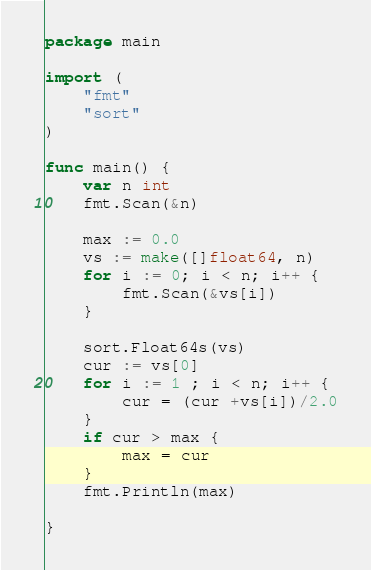Convert code to text. <code><loc_0><loc_0><loc_500><loc_500><_Go_>package main

import (
	"fmt"
	"sort"
)

func main() {
	var n int
	fmt.Scan(&n)

	max := 0.0
	vs := make([]float64, n)
	for i := 0; i < n; i++ {
		fmt.Scan(&vs[i])
	}

	sort.Float64s(vs)
	cur := vs[0]
	for i := 1 ; i < n; i++ {
		cur = (cur +vs[i])/2.0
	}
	if cur > max {
		max = cur
	}
	fmt.Println(max)

}
</code> 